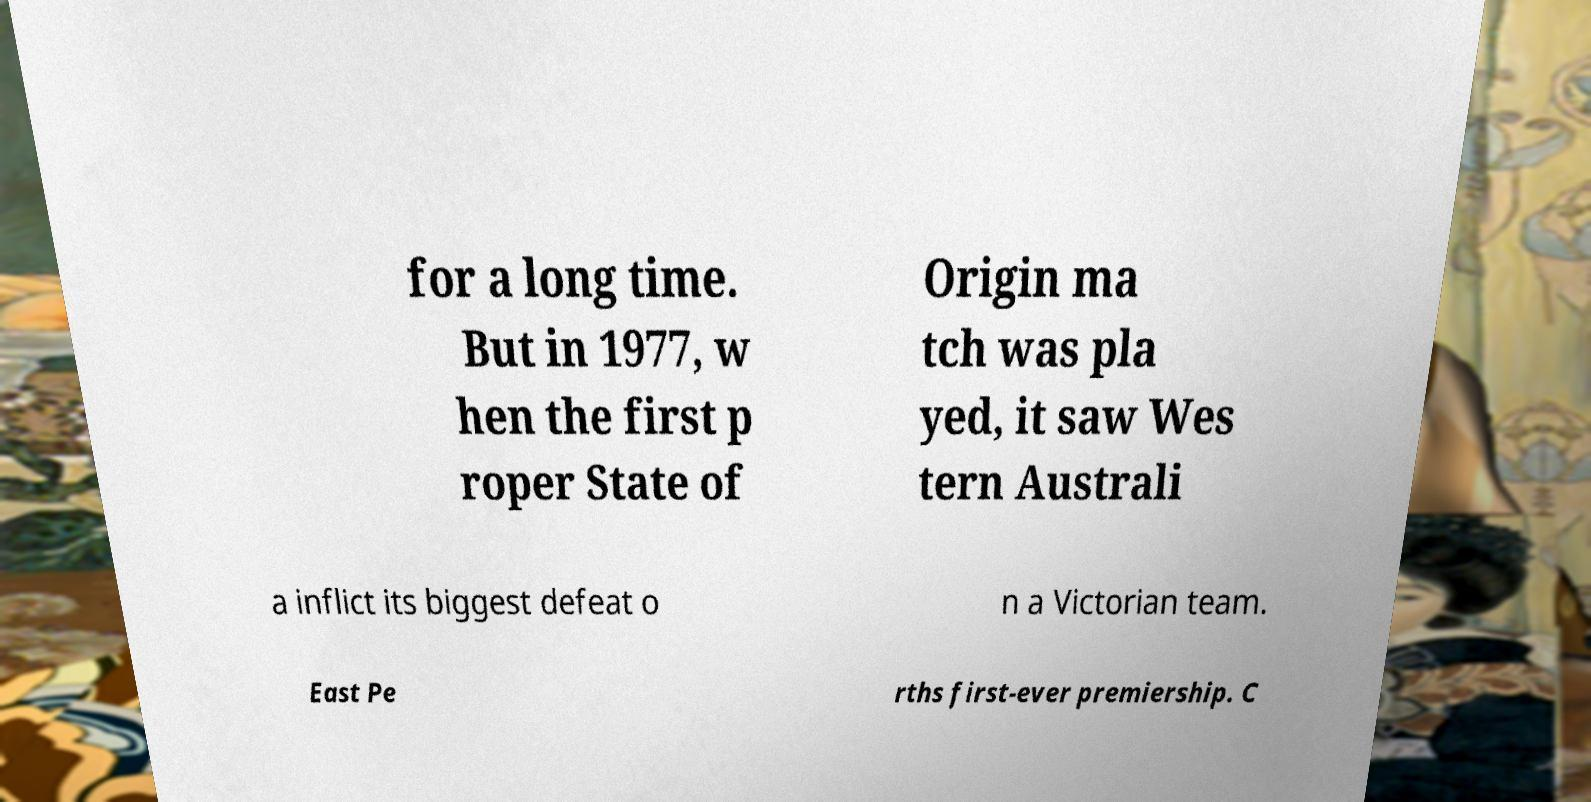Could you assist in decoding the text presented in this image and type it out clearly? for a long time. But in 1977, w hen the first p roper State of Origin ma tch was pla yed, it saw Wes tern Australi a inflict its biggest defeat o n a Victorian team. East Pe rths first-ever premiership. C 